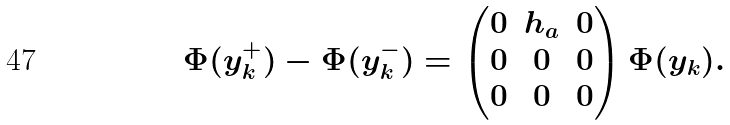<formula> <loc_0><loc_0><loc_500><loc_500>\Phi ( y _ { k } ^ { + } ) - \Phi ( y _ { k } ^ { - } ) = \begin{pmatrix} 0 & h _ { a } & 0 \\ 0 & 0 & 0 \\ 0 & 0 & 0 \end{pmatrix} \Phi ( y _ { k } ) .</formula> 